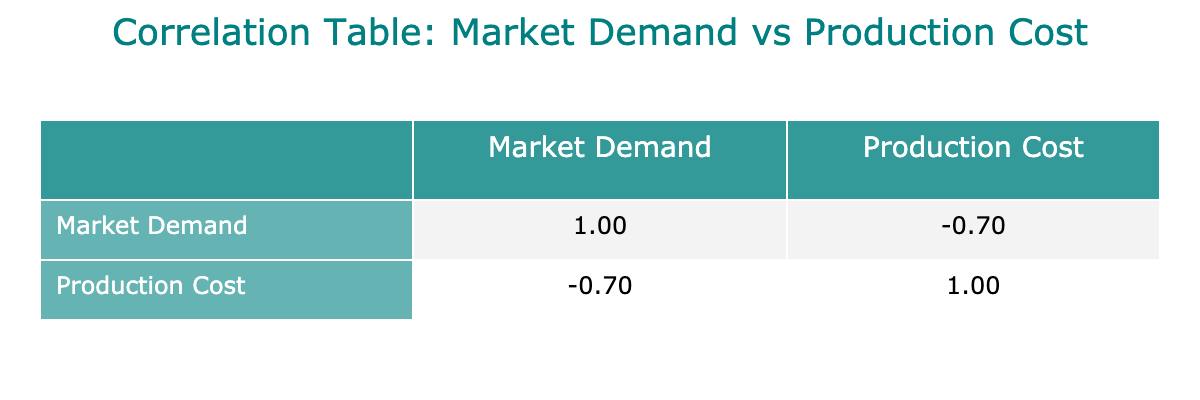What is the market demand for Deep Groove Ball Bearings? The table states that the market demand for Deep Groove Ball Bearings is listed under the "Market Demand" column. According to the table, it is 120,000 units.
Answer: 120,000 units What is the production cost per unit for Ceramic Bearings? The production cost for Ceramic Bearings is found in the "Production Cost" column for that specific row. The table indicates a cost of 20.00 USD.
Answer: 20.00 USD Is the market demand for Angular Contact Ball Bearings greater than 60,000 units? The table shows that Angular Contact Ball Bearings have a market demand of 70,000 units. Since 70,000 is greater than 60,000, the answer is yes.
Answer: Yes What is the total market demand for Needle Bearings and Thrust Bearings combined? The market demand for Needle Bearings is 80,000 units and for Thrust Bearings, it is 30,000 units. Adding these together gives 80,000 + 30,000 = 110,000 units.
Answer: 110,000 units Are the production costs for all bearing types above $5.00? The production costs for each bearing type listed show at least one type (Needle Bearings at $4.50) below $5.00. Therefore, not all production costs are above $5.00.
Answer: No What is the average production cost per unit of all listed bearings? First, add the production costs: 5.50 + 7.25 + 12.00 + 9.00 + 15.00 + 4.50 + 10.00 + 20.00 = 83.25 USD. There are 8 bearing types, so the average is 83.25 / 8 = approximately 10.41 USD.
Answer: 10.41 USD Which bearing type has the highest market demand and what is that demand? By examining the "Market Demand" column, Deep Groove Ball Bearings have the highest demand at 120,000 units.
Answer: 120,000 units If the production cost for Deep Groove Ball Bearings increases to $6.00, how much would the average production cost increase? The original cost for Deep Groove Ball Bearings is 5.50 USD and the new cost will be 6.00 USD. The increase is 6.00 - 5.50 = 0.50 USD.
Answer: 0.50 USD What is the difference in market demand between Spherical Roller Bearings and Self-Aligning Ball Bearings? Spherical Roller Bearings have a market demand of 45,000 units, and Self-Aligning Ball Bearings have 50,000 units. The difference is 50,000 - 45,000 = 5,000 units.
Answer: 5,000 units 